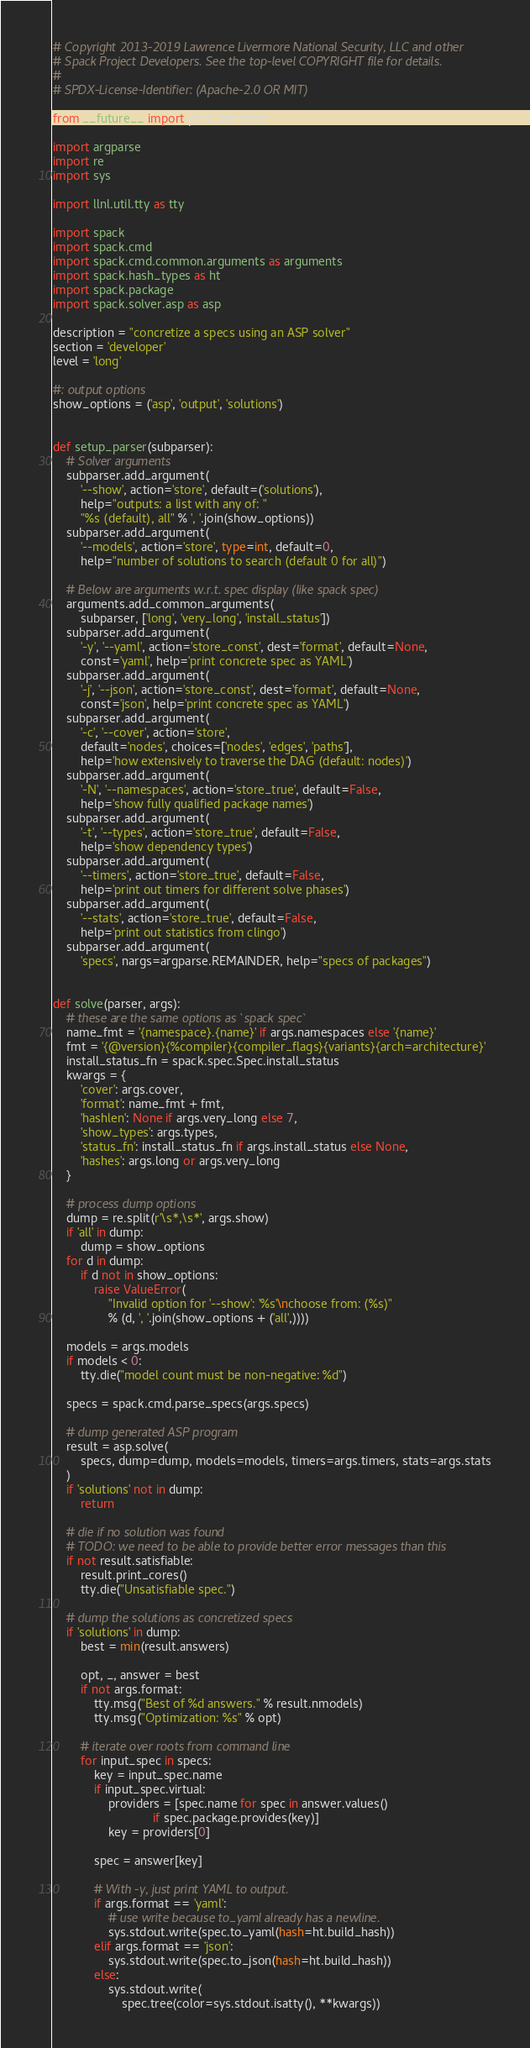Convert code to text. <code><loc_0><loc_0><loc_500><loc_500><_Python_># Copyright 2013-2019 Lawrence Livermore National Security, LLC and other
# Spack Project Developers. See the top-level COPYRIGHT file for details.
#
# SPDX-License-Identifier: (Apache-2.0 OR MIT)

from __future__ import print_function

import argparse
import re
import sys

import llnl.util.tty as tty

import spack
import spack.cmd
import spack.cmd.common.arguments as arguments
import spack.hash_types as ht
import spack.package
import spack.solver.asp as asp

description = "concretize a specs using an ASP solver"
section = 'developer'
level = 'long'

#: output options
show_options = ('asp', 'output', 'solutions')


def setup_parser(subparser):
    # Solver arguments
    subparser.add_argument(
        '--show', action='store', default=('solutions'),
        help="outputs: a list with any of: "
        "%s (default), all" % ', '.join(show_options))
    subparser.add_argument(
        '--models', action='store', type=int, default=0,
        help="number of solutions to search (default 0 for all)")

    # Below are arguments w.r.t. spec display (like spack spec)
    arguments.add_common_arguments(
        subparser, ['long', 'very_long', 'install_status'])
    subparser.add_argument(
        '-y', '--yaml', action='store_const', dest='format', default=None,
        const='yaml', help='print concrete spec as YAML')
    subparser.add_argument(
        '-j', '--json', action='store_const', dest='format', default=None,
        const='json', help='print concrete spec as YAML')
    subparser.add_argument(
        '-c', '--cover', action='store',
        default='nodes', choices=['nodes', 'edges', 'paths'],
        help='how extensively to traverse the DAG (default: nodes)')
    subparser.add_argument(
        '-N', '--namespaces', action='store_true', default=False,
        help='show fully qualified package names')
    subparser.add_argument(
        '-t', '--types', action='store_true', default=False,
        help='show dependency types')
    subparser.add_argument(
        '--timers', action='store_true', default=False,
        help='print out timers for different solve phases')
    subparser.add_argument(
        '--stats', action='store_true', default=False,
        help='print out statistics from clingo')
    subparser.add_argument(
        'specs', nargs=argparse.REMAINDER, help="specs of packages")


def solve(parser, args):
    # these are the same options as `spack spec`
    name_fmt = '{namespace}.{name}' if args.namespaces else '{name}'
    fmt = '{@version}{%compiler}{compiler_flags}{variants}{arch=architecture}'
    install_status_fn = spack.spec.Spec.install_status
    kwargs = {
        'cover': args.cover,
        'format': name_fmt + fmt,
        'hashlen': None if args.very_long else 7,
        'show_types': args.types,
        'status_fn': install_status_fn if args.install_status else None,
        'hashes': args.long or args.very_long
    }

    # process dump options
    dump = re.split(r'\s*,\s*', args.show)
    if 'all' in dump:
        dump = show_options
    for d in dump:
        if d not in show_options:
            raise ValueError(
                "Invalid option for '--show': '%s'\nchoose from: (%s)"
                % (d, ', '.join(show_options + ('all',))))

    models = args.models
    if models < 0:
        tty.die("model count must be non-negative: %d")

    specs = spack.cmd.parse_specs(args.specs)

    # dump generated ASP program
    result = asp.solve(
        specs, dump=dump, models=models, timers=args.timers, stats=args.stats
    )
    if 'solutions' not in dump:
        return

    # die if no solution was found
    # TODO: we need to be able to provide better error messages than this
    if not result.satisfiable:
        result.print_cores()
        tty.die("Unsatisfiable spec.")

    # dump the solutions as concretized specs
    if 'solutions' in dump:
        best = min(result.answers)

        opt, _, answer = best
        if not args.format:
            tty.msg("Best of %d answers." % result.nmodels)
            tty.msg("Optimization: %s" % opt)

        # iterate over roots from command line
        for input_spec in specs:
            key = input_spec.name
            if input_spec.virtual:
                providers = [spec.name for spec in answer.values()
                             if spec.package.provides(key)]
                key = providers[0]

            spec = answer[key]

            # With -y, just print YAML to output.
            if args.format == 'yaml':
                # use write because to_yaml already has a newline.
                sys.stdout.write(spec.to_yaml(hash=ht.build_hash))
            elif args.format == 'json':
                sys.stdout.write(spec.to_json(hash=ht.build_hash))
            else:
                sys.stdout.write(
                    spec.tree(color=sys.stdout.isatty(), **kwargs))
</code> 